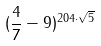<formula> <loc_0><loc_0><loc_500><loc_500>( \frac { 4 } { 7 } - 9 ) ^ { 2 0 4 \cdot \sqrt { 5 } }</formula> 